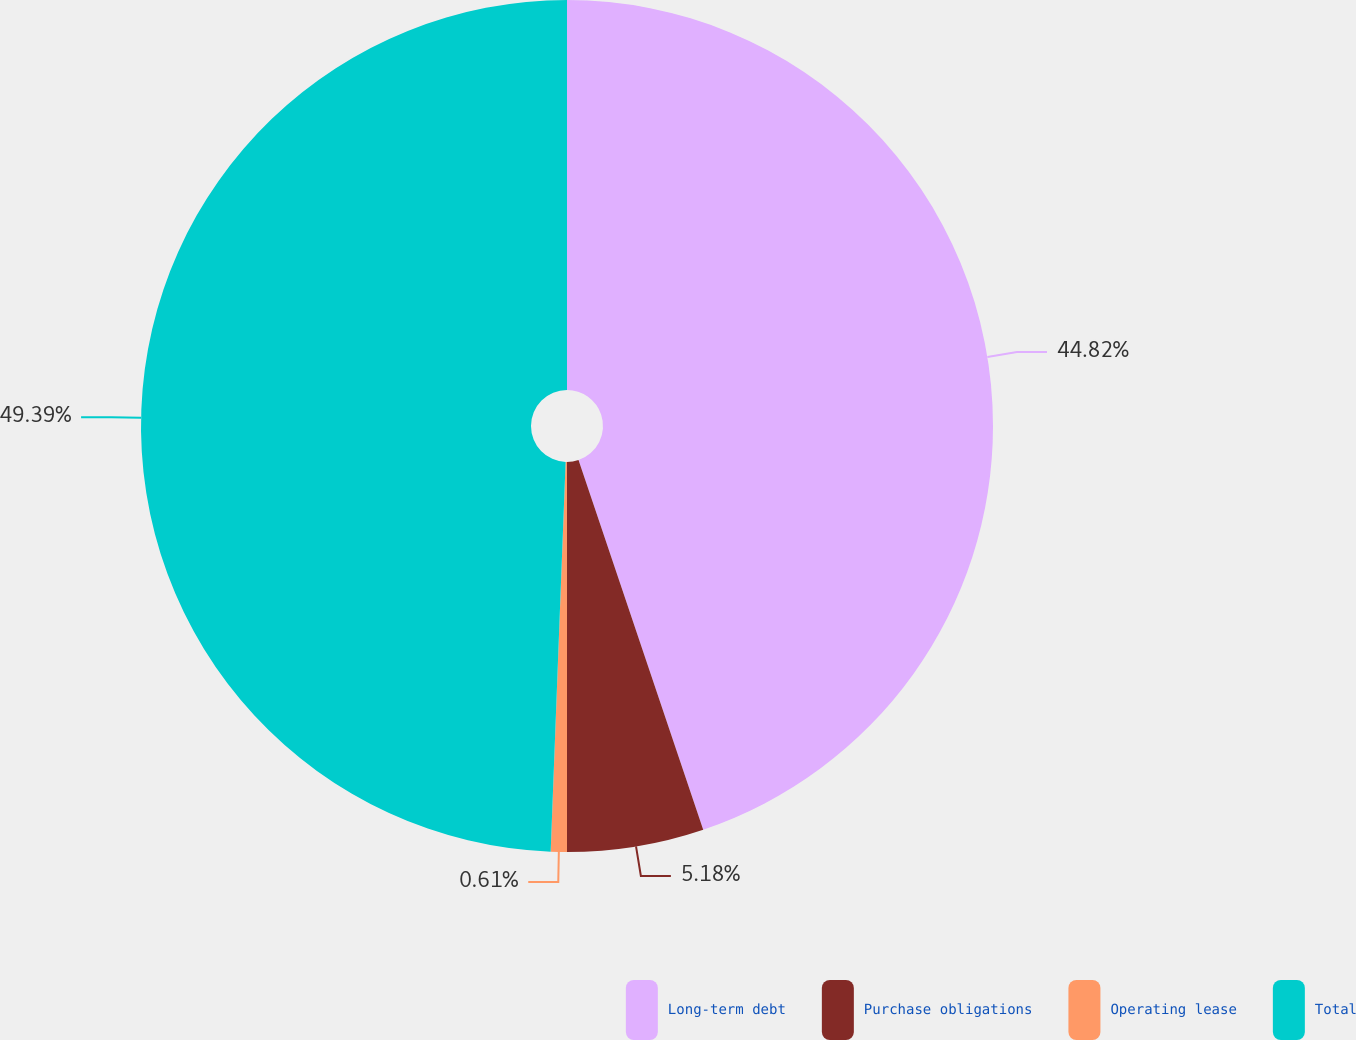Convert chart. <chart><loc_0><loc_0><loc_500><loc_500><pie_chart><fcel>Long-term debt<fcel>Purchase obligations<fcel>Operating lease<fcel>Total<nl><fcel>44.82%<fcel>5.18%<fcel>0.61%<fcel>49.39%<nl></chart> 